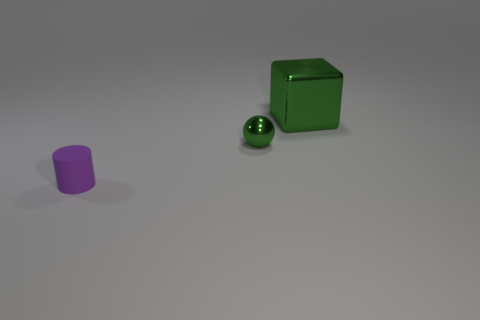Is there anything else that has the same shape as the small purple matte object?
Ensure brevity in your answer.  No. There is a object that is behind the small thing to the right of the cylinder; are there any objects in front of it?
Keep it short and to the point. Yes. The large object has what shape?
Ensure brevity in your answer.  Cube. Do the thing that is to the right of the green ball and the green thing that is in front of the big green shiny cube have the same material?
Give a very brief answer. Yes. How many large blocks have the same color as the metallic sphere?
Your response must be concise. 1. What is the shape of the thing that is both in front of the green metallic cube and behind the tiny purple matte cylinder?
Your response must be concise. Sphere. There is a object that is both behind the purple matte cylinder and in front of the large block; what is its color?
Provide a short and direct response. Green. Are there more small things on the left side of the cube than purple cylinders in front of the matte object?
Make the answer very short. Yes. What is the color of the tiny thing that is to the right of the tiny cylinder?
Give a very brief answer. Green. Does the small thing behind the rubber object have the same shape as the metal thing that is right of the tiny green shiny sphere?
Provide a succinct answer. No. 